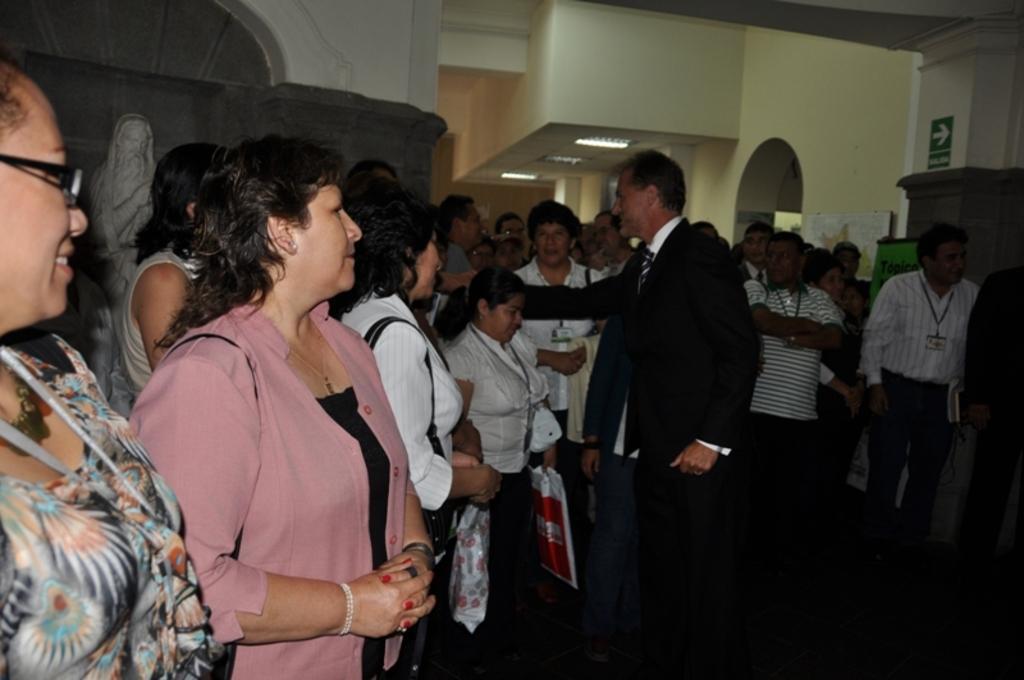In one or two sentences, can you explain what this image depicts? In this image I can see group of people standing. There are boards, walls, lights and there is a sculpture. 